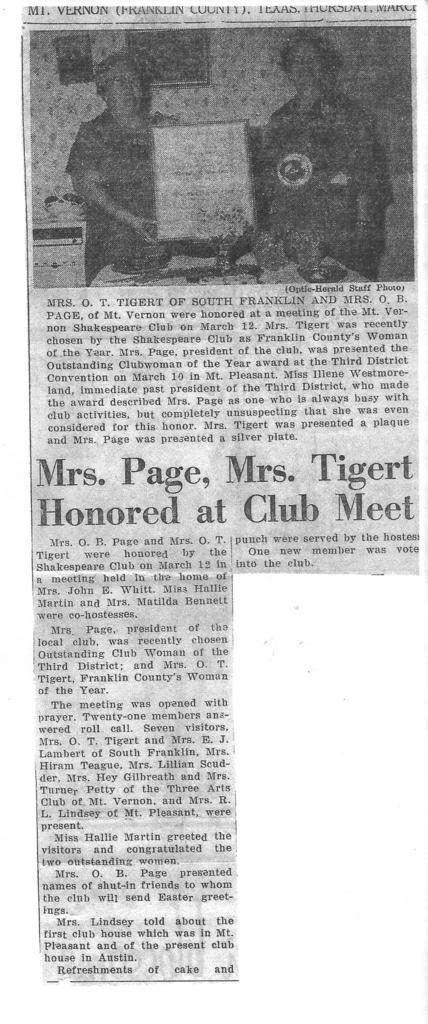Please provide a concise description of this image. In this image I can see a newspaper article and on top of the image I can see a picture of two persons standing and holding a white colored board. I can see this is a black and white picture. 